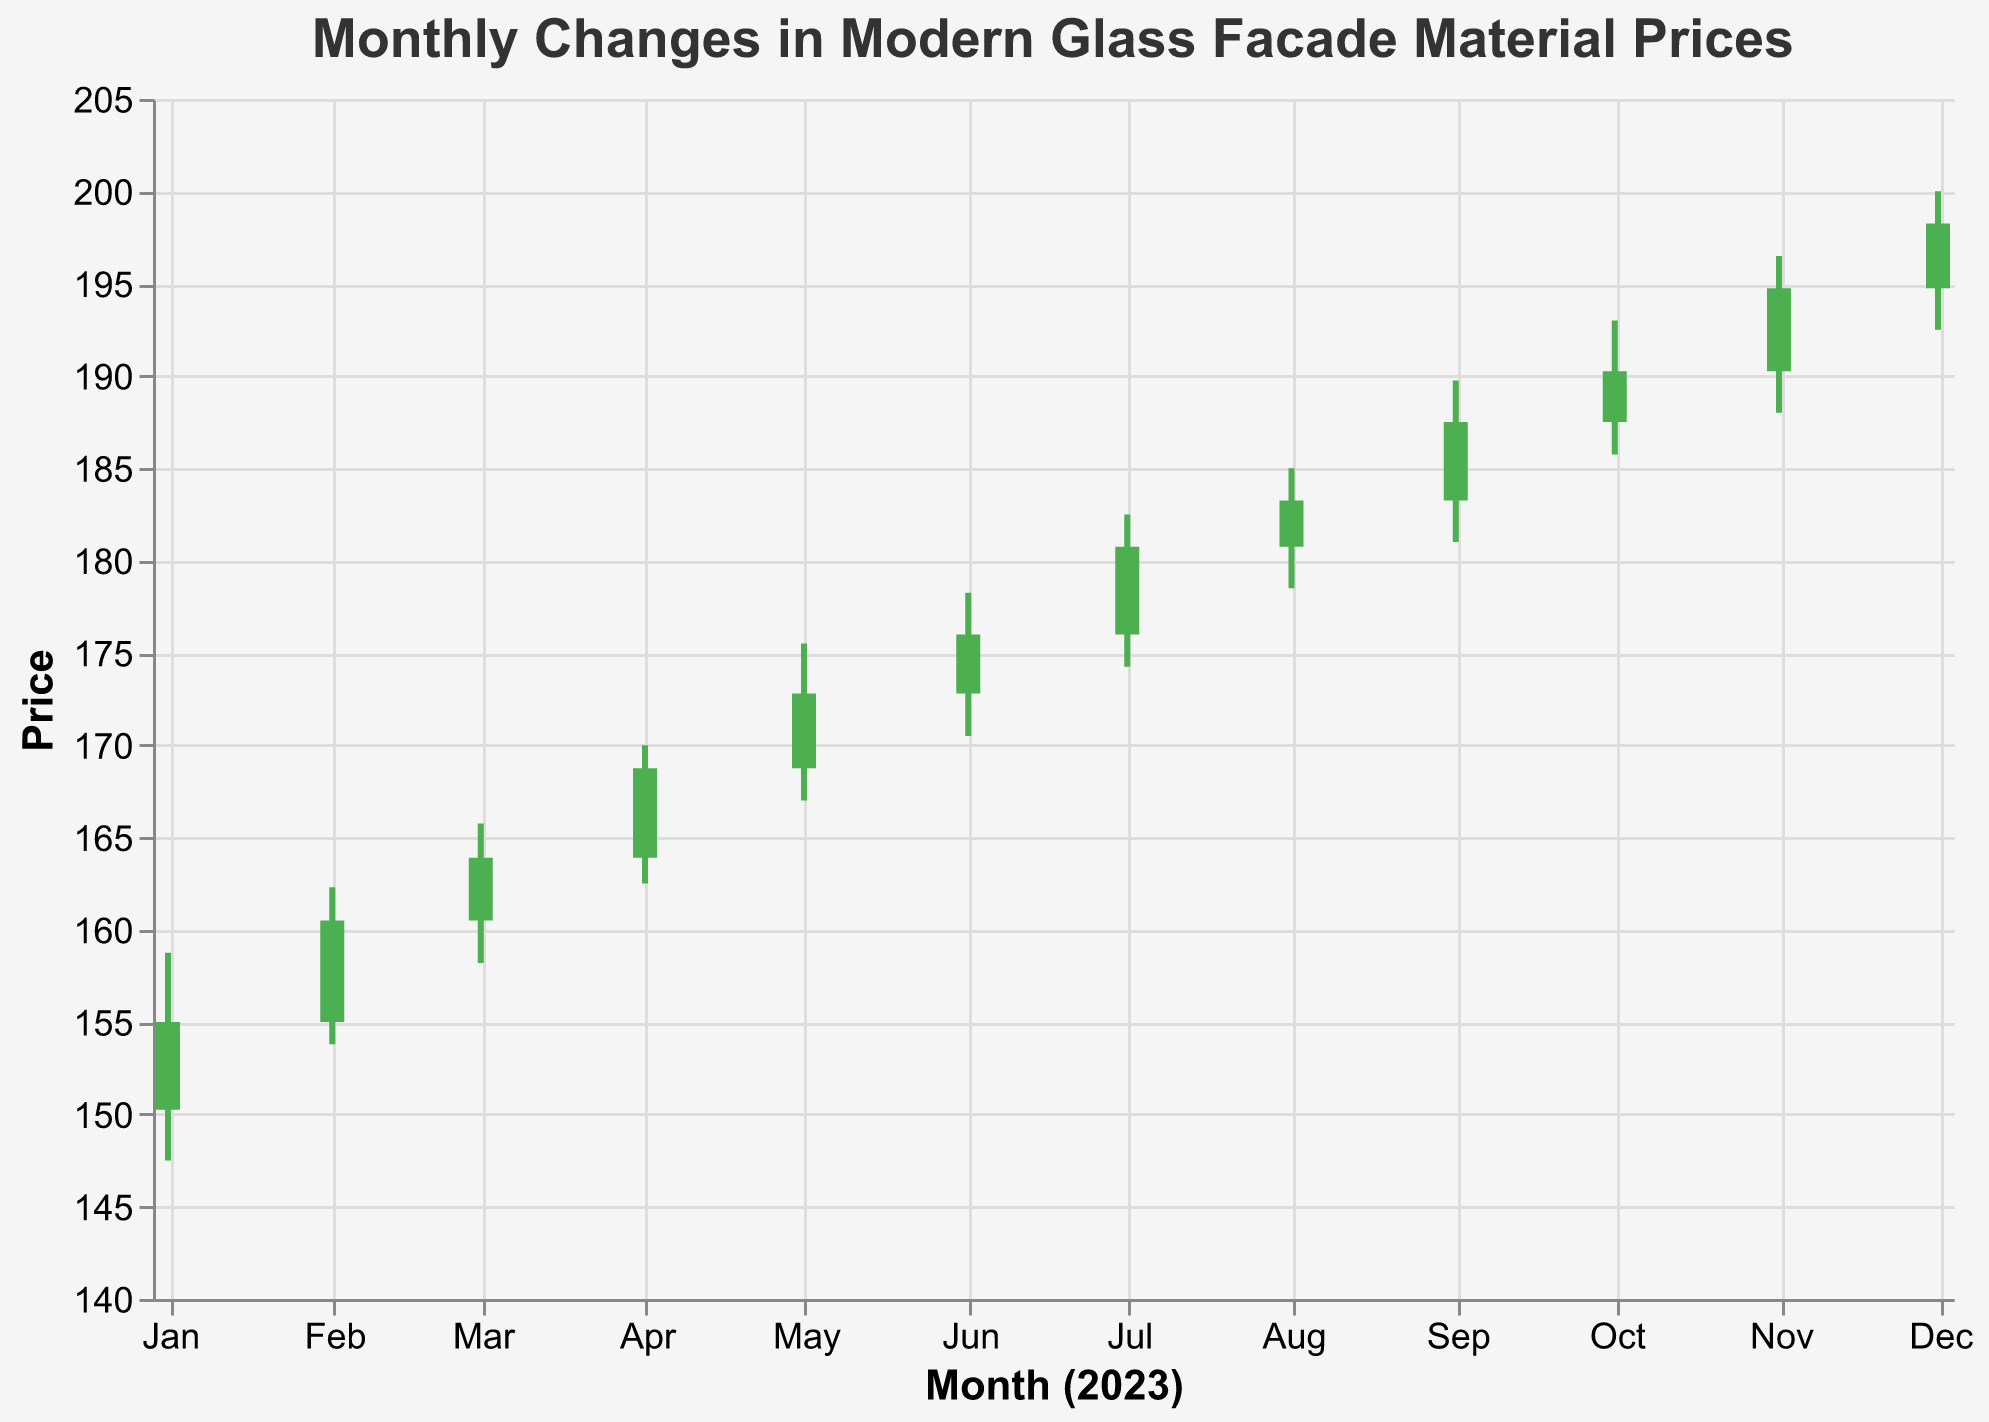What is the title of the figure? The title is typically located at the top of the figure, in this case, it is "Monthly Changes in Modern Glass Facade Material Prices"
Answer: Monthly Changes in Modern Glass Facade Material Prices How many data points are shown in the figure? By counting each month listed from January to December, there are 12 data points shown
Answer: 12 Which month had the highest closing price? The closing prices for each month need to be compared, and December had the highest closing price of 198.25
Answer: December What is the price range for September? For September, look at the high and low prices, which are 189.75 and 181.00 respectively. The range is 189.75 - 181.00
Answer: 8.75 In which month did the price decrease? Check each month's opening and closing prices. The only month where the opening price is higher than the closing price is none, prices increased every month
Answer: None What is the trend of the closing prices throughout the year? To determine the trend, analyze the closing prices from January (155.00) to December (198.25). The overall trend is upward
Answer: Upward Which month experienced the most market volatility, defined by the largest difference between high and low prices? Calculate the difference between high and low prices for each month. August has the largest volatility with high 185.00 and low 178.50, the difference is 6.50
Answer: August What color represents a month where prices increased? As observed in the visual, months with rising prices are marked in green
Answer: Green What was the opening price in June, and how does it compare to its closing price? The opening price in June was 172.80 and the closing price was 176.00. This shows an increase of 3.20
Answer: Increased by 3.20 Did any month have the same opening and closing price? Compare each month's opening and closing prices. None of the months had identical opening and closing prices
Answer: No 